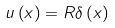<formula> <loc_0><loc_0><loc_500><loc_500>u \left ( x \right ) = R \delta \left ( x \right )</formula> 